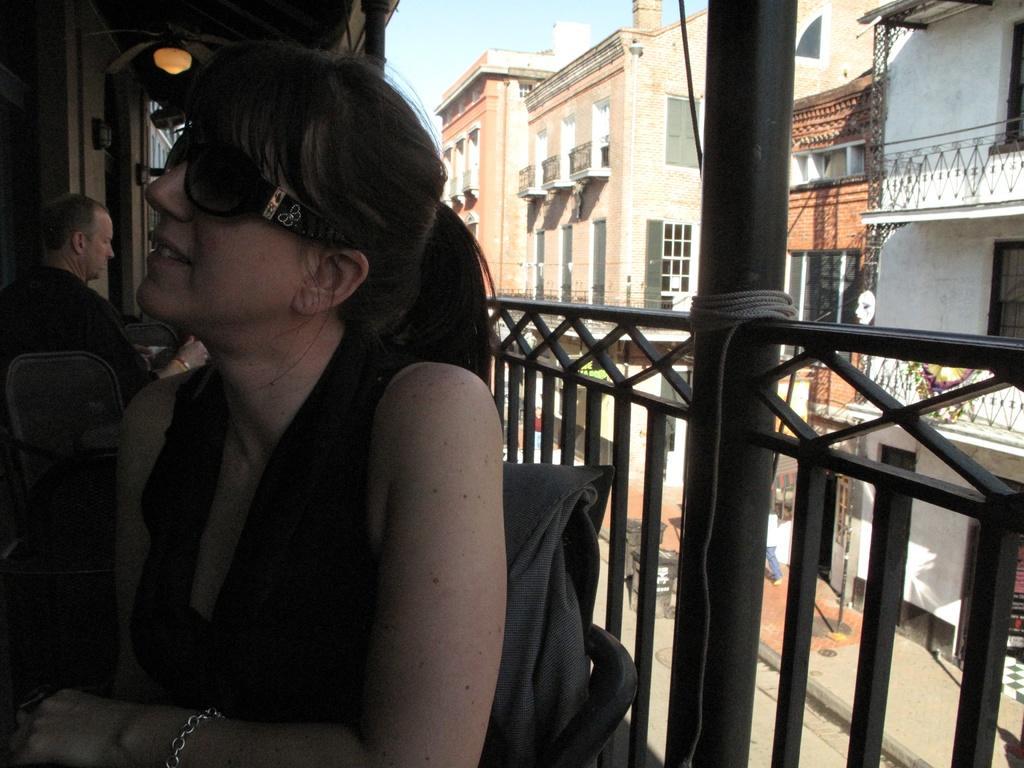How would you summarize this image in a sentence or two? In the picture I can see a woman wearing a black color dress and glasses is sitting on the chair. Here we can see steel railing, we can see a person also sitting on the chair near the table. In the background, we can see ceiling lights, buildings, trash cans on the road and the sky. 